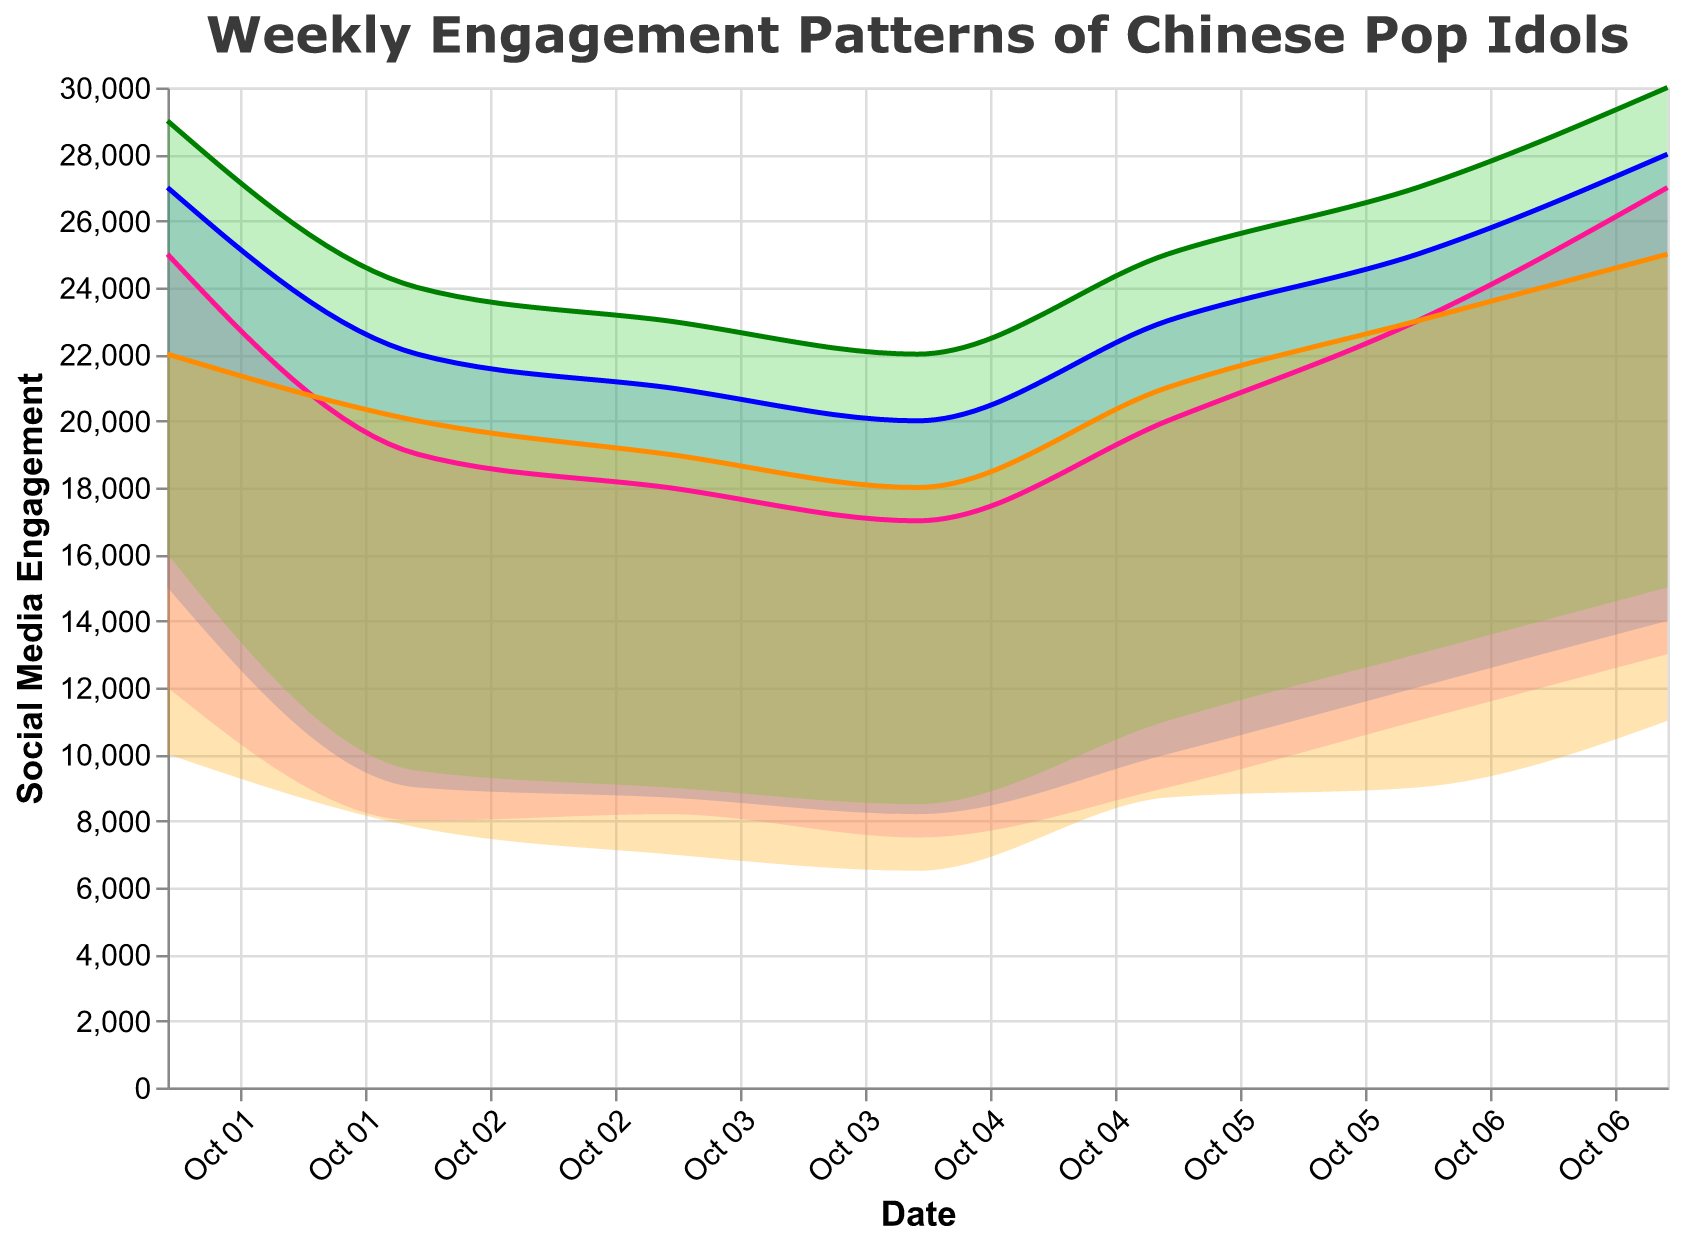What day shows the highest maximum engagement for Huang Zitao? The highest maximum engagement for Huang Zitao is shown as 27,000. Checking the data, this occurs on Saturday.
Answer: Saturday Which day has the lowest minimum engagement for Jackson Wang? The lowest minimum engagement for Jackson Wang is 6,500. Referring to the data, this happens on Wednesday.
Answer: Wednesday Compare the maximum engagement of Huang Zitao and Lay Zhang on Friday. Which one is higher? On Friday, Huang Zitao's maximum engagement is 23,000. Lay Zhang's is 25,000. Lay Zhang's maximum engagement is higher on Friday.
Answer: Lay Zhang What is the range of engagement for Luhan on Tuesday? The range of engagement is calculated by subtracting the minimum engagement from the maximum engagement. For Luhan, on Tuesday, it is 23,000 - 9,000 = 14,000.
Answer: 14,000 On which day does Lay Zhang have the maximum engagement, and what is the value? Lay Zhang's maximum engagement value is highest on Sunday at 27,000.
Answer: Sunday, 27,000 What is the combined maximum engagement of all four idols on Thursday? Adding the maximum engagements on Thursday: Huang Zitao (20,000) + Lay Zhang (23,000) + Luhan (25,000) + Jackson Wang (21,000) = 89,000.
Answer: 89,000 How does the engagement pattern for Huang Zitao on Saturday compare to Sunday in terms of the ranges? On Saturday, Huang Zitao's range is from 13,000 to 27,000, and on Sunday, it's from 12,000 to 25,000. The range on Saturday is both higher and has a wider spread compared to Sunday.
Answer: Higher and wider on Saturday Which day has the smallest engagement range for Luhan, and what is that range? The smallest engagement range for Luhan is on Wednesday with 22,000 - 8,500 = 13,500.
Answer: Wednesday, 13,500 Identify the idol with the lowest minimum engagement on any given day and specify the day and engagement value. The lowest minimum engagement value is 6,500 for Jackson Wang on Wednesday.
Answer: Jackson Wang, Wednesday, 6,500 